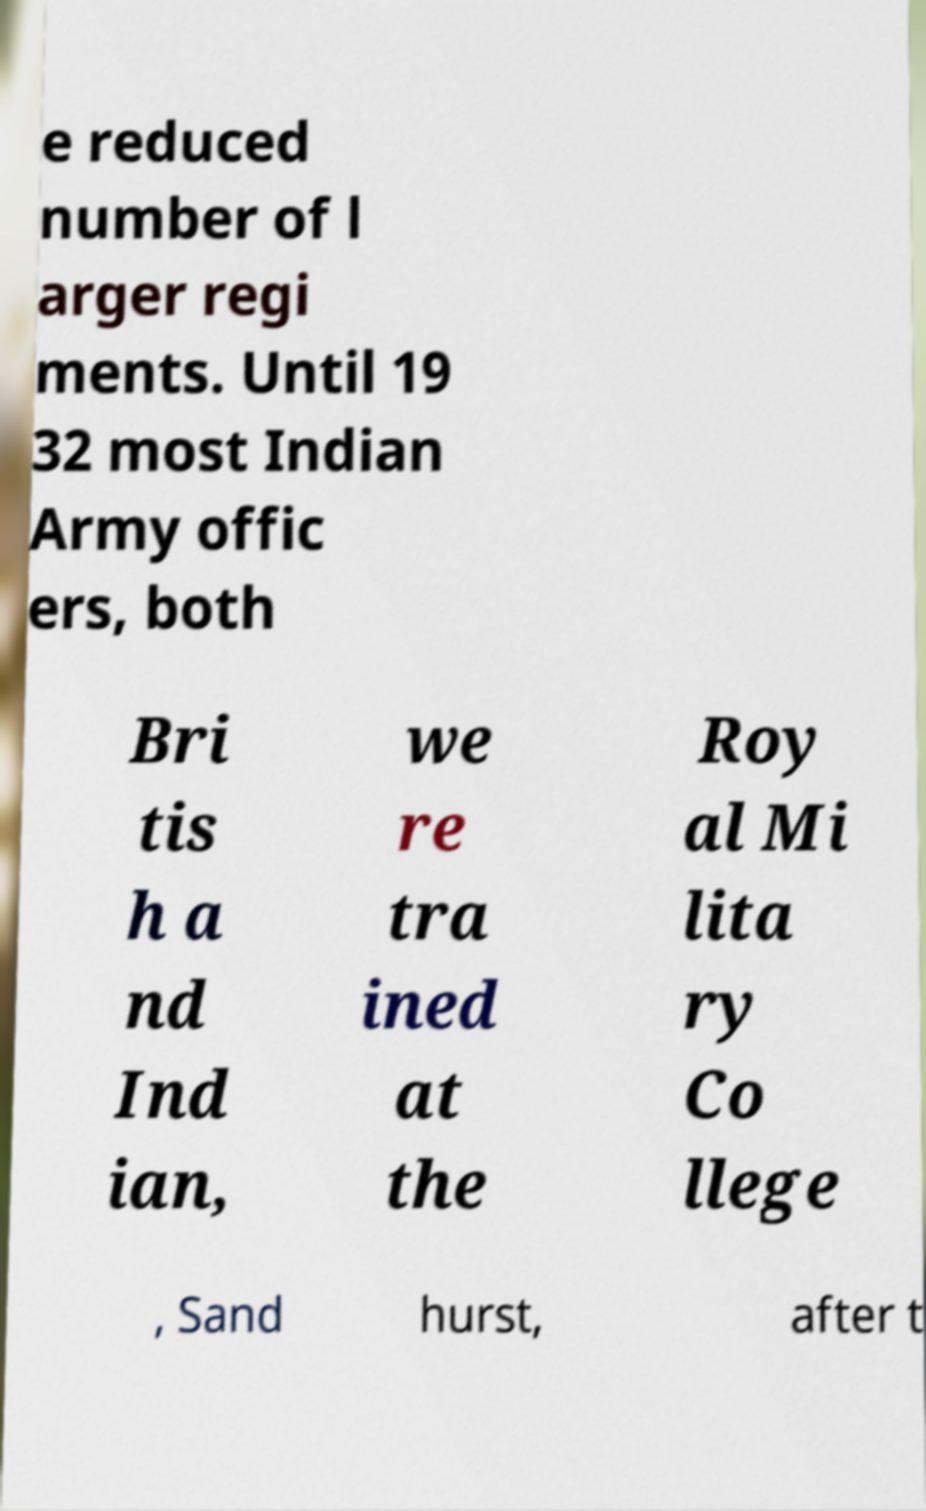There's text embedded in this image that I need extracted. Can you transcribe it verbatim? e reduced number of l arger regi ments. Until 19 32 most Indian Army offic ers, both Bri tis h a nd Ind ian, we re tra ined at the Roy al Mi lita ry Co llege , Sand hurst, after t 